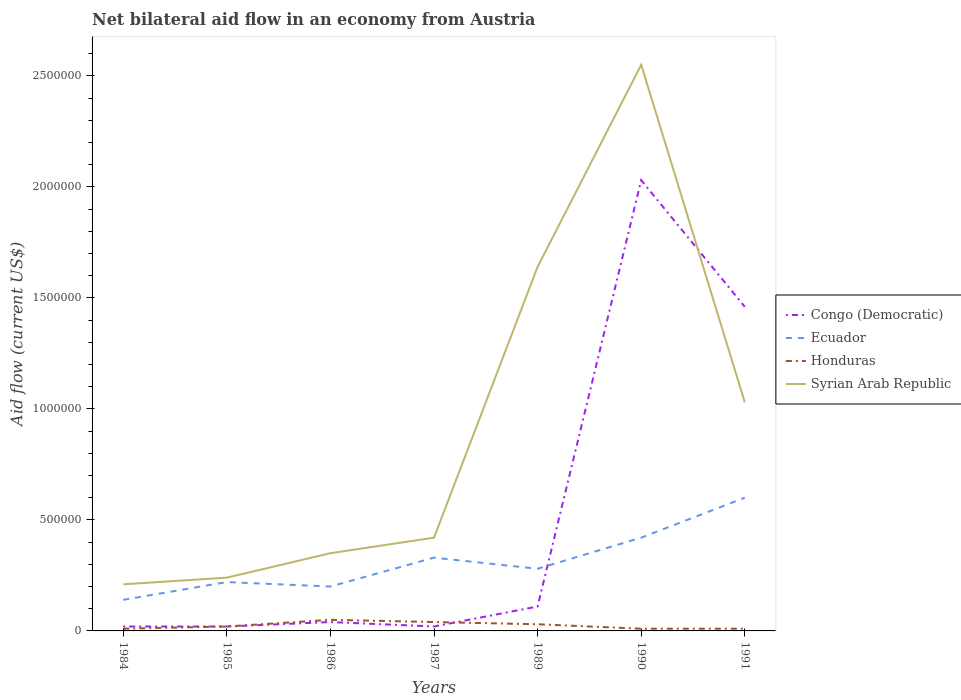How many different coloured lines are there?
Offer a very short reply. 4. Is the number of lines equal to the number of legend labels?
Keep it short and to the point. Yes. Across all years, what is the maximum net bilateral aid flow in Congo (Democratic)?
Ensure brevity in your answer.  2.00e+04. What is the total net bilateral aid flow in Ecuador in the graph?
Make the answer very short. -4.00e+05. What is the difference between the highest and the second highest net bilateral aid flow in Honduras?
Ensure brevity in your answer.  4.00e+04. How are the legend labels stacked?
Keep it short and to the point. Vertical. What is the title of the graph?
Your answer should be compact. Net bilateral aid flow in an economy from Austria. What is the label or title of the Y-axis?
Your answer should be very brief. Aid flow (current US$). What is the Aid flow (current US$) in Congo (Democratic) in 1984?
Your answer should be compact. 2.00e+04. What is the Aid flow (current US$) of Ecuador in 1984?
Provide a succinct answer. 1.40e+05. What is the Aid flow (current US$) of Congo (Democratic) in 1985?
Make the answer very short. 2.00e+04. What is the Aid flow (current US$) of Ecuador in 1985?
Make the answer very short. 2.20e+05. What is the Aid flow (current US$) in Honduras in 1985?
Ensure brevity in your answer.  2.00e+04. What is the Aid flow (current US$) of Syrian Arab Republic in 1985?
Your answer should be compact. 2.40e+05. What is the Aid flow (current US$) in Ecuador in 1986?
Ensure brevity in your answer.  2.00e+05. What is the Aid flow (current US$) of Honduras in 1986?
Offer a very short reply. 5.00e+04. What is the Aid flow (current US$) of Syrian Arab Republic in 1986?
Provide a short and direct response. 3.50e+05. What is the Aid flow (current US$) of Syrian Arab Republic in 1987?
Provide a succinct answer. 4.20e+05. What is the Aid flow (current US$) of Honduras in 1989?
Your answer should be very brief. 3.00e+04. What is the Aid flow (current US$) of Syrian Arab Republic in 1989?
Ensure brevity in your answer.  1.64e+06. What is the Aid flow (current US$) of Congo (Democratic) in 1990?
Provide a short and direct response. 2.03e+06. What is the Aid flow (current US$) of Ecuador in 1990?
Provide a short and direct response. 4.20e+05. What is the Aid flow (current US$) of Honduras in 1990?
Make the answer very short. 10000. What is the Aid flow (current US$) in Syrian Arab Republic in 1990?
Your response must be concise. 2.55e+06. What is the Aid flow (current US$) of Congo (Democratic) in 1991?
Provide a short and direct response. 1.46e+06. What is the Aid flow (current US$) in Honduras in 1991?
Ensure brevity in your answer.  10000. What is the Aid flow (current US$) of Syrian Arab Republic in 1991?
Your answer should be compact. 1.03e+06. Across all years, what is the maximum Aid flow (current US$) of Congo (Democratic)?
Keep it short and to the point. 2.03e+06. Across all years, what is the maximum Aid flow (current US$) of Honduras?
Ensure brevity in your answer.  5.00e+04. Across all years, what is the maximum Aid flow (current US$) in Syrian Arab Republic?
Make the answer very short. 2.55e+06. Across all years, what is the minimum Aid flow (current US$) of Congo (Democratic)?
Provide a succinct answer. 2.00e+04. Across all years, what is the minimum Aid flow (current US$) in Ecuador?
Keep it short and to the point. 1.40e+05. Across all years, what is the minimum Aid flow (current US$) in Honduras?
Offer a terse response. 10000. What is the total Aid flow (current US$) of Congo (Democratic) in the graph?
Make the answer very short. 3.70e+06. What is the total Aid flow (current US$) in Ecuador in the graph?
Your answer should be compact. 2.19e+06. What is the total Aid flow (current US$) in Syrian Arab Republic in the graph?
Ensure brevity in your answer.  6.44e+06. What is the difference between the Aid flow (current US$) of Congo (Democratic) in 1984 and that in 1985?
Your answer should be compact. 0. What is the difference between the Aid flow (current US$) of Ecuador in 1984 and that in 1985?
Offer a very short reply. -8.00e+04. What is the difference between the Aid flow (current US$) in Honduras in 1984 and that in 1985?
Offer a terse response. -10000. What is the difference between the Aid flow (current US$) in Congo (Democratic) in 1984 and that in 1986?
Offer a very short reply. -2.00e+04. What is the difference between the Aid flow (current US$) of Ecuador in 1984 and that in 1986?
Your answer should be compact. -6.00e+04. What is the difference between the Aid flow (current US$) in Congo (Democratic) in 1984 and that in 1987?
Your answer should be compact. 0. What is the difference between the Aid flow (current US$) in Ecuador in 1984 and that in 1987?
Offer a terse response. -1.90e+05. What is the difference between the Aid flow (current US$) in Syrian Arab Republic in 1984 and that in 1987?
Provide a short and direct response. -2.10e+05. What is the difference between the Aid flow (current US$) of Congo (Democratic) in 1984 and that in 1989?
Provide a short and direct response. -9.00e+04. What is the difference between the Aid flow (current US$) in Honduras in 1984 and that in 1989?
Provide a succinct answer. -2.00e+04. What is the difference between the Aid flow (current US$) of Syrian Arab Republic in 1984 and that in 1989?
Make the answer very short. -1.43e+06. What is the difference between the Aid flow (current US$) in Congo (Democratic) in 1984 and that in 1990?
Make the answer very short. -2.01e+06. What is the difference between the Aid flow (current US$) of Ecuador in 1984 and that in 1990?
Your answer should be compact. -2.80e+05. What is the difference between the Aid flow (current US$) of Honduras in 1984 and that in 1990?
Provide a short and direct response. 0. What is the difference between the Aid flow (current US$) of Syrian Arab Republic in 1984 and that in 1990?
Make the answer very short. -2.34e+06. What is the difference between the Aid flow (current US$) in Congo (Democratic) in 1984 and that in 1991?
Make the answer very short. -1.44e+06. What is the difference between the Aid flow (current US$) of Ecuador in 1984 and that in 1991?
Offer a terse response. -4.60e+05. What is the difference between the Aid flow (current US$) of Syrian Arab Republic in 1984 and that in 1991?
Offer a terse response. -8.20e+05. What is the difference between the Aid flow (current US$) in Ecuador in 1985 and that in 1986?
Ensure brevity in your answer.  2.00e+04. What is the difference between the Aid flow (current US$) of Honduras in 1985 and that in 1987?
Keep it short and to the point. -2.00e+04. What is the difference between the Aid flow (current US$) in Syrian Arab Republic in 1985 and that in 1987?
Provide a short and direct response. -1.80e+05. What is the difference between the Aid flow (current US$) in Ecuador in 1985 and that in 1989?
Your answer should be very brief. -6.00e+04. What is the difference between the Aid flow (current US$) of Honduras in 1985 and that in 1989?
Your answer should be very brief. -10000. What is the difference between the Aid flow (current US$) in Syrian Arab Republic in 1985 and that in 1989?
Offer a very short reply. -1.40e+06. What is the difference between the Aid flow (current US$) of Congo (Democratic) in 1985 and that in 1990?
Provide a short and direct response. -2.01e+06. What is the difference between the Aid flow (current US$) of Ecuador in 1985 and that in 1990?
Make the answer very short. -2.00e+05. What is the difference between the Aid flow (current US$) in Syrian Arab Republic in 1985 and that in 1990?
Make the answer very short. -2.31e+06. What is the difference between the Aid flow (current US$) of Congo (Democratic) in 1985 and that in 1991?
Provide a succinct answer. -1.44e+06. What is the difference between the Aid flow (current US$) in Ecuador in 1985 and that in 1991?
Your response must be concise. -3.80e+05. What is the difference between the Aid flow (current US$) of Honduras in 1985 and that in 1991?
Provide a short and direct response. 10000. What is the difference between the Aid flow (current US$) of Syrian Arab Republic in 1985 and that in 1991?
Keep it short and to the point. -7.90e+05. What is the difference between the Aid flow (current US$) of Congo (Democratic) in 1986 and that in 1987?
Your response must be concise. 2.00e+04. What is the difference between the Aid flow (current US$) of Ecuador in 1986 and that in 1987?
Provide a succinct answer. -1.30e+05. What is the difference between the Aid flow (current US$) of Honduras in 1986 and that in 1987?
Your answer should be compact. 10000. What is the difference between the Aid flow (current US$) in Ecuador in 1986 and that in 1989?
Make the answer very short. -8.00e+04. What is the difference between the Aid flow (current US$) in Honduras in 1986 and that in 1989?
Your answer should be very brief. 2.00e+04. What is the difference between the Aid flow (current US$) of Syrian Arab Republic in 1986 and that in 1989?
Your answer should be compact. -1.29e+06. What is the difference between the Aid flow (current US$) of Congo (Democratic) in 1986 and that in 1990?
Offer a terse response. -1.99e+06. What is the difference between the Aid flow (current US$) in Ecuador in 1986 and that in 1990?
Offer a terse response. -2.20e+05. What is the difference between the Aid flow (current US$) in Syrian Arab Republic in 1986 and that in 1990?
Your answer should be compact. -2.20e+06. What is the difference between the Aid flow (current US$) in Congo (Democratic) in 1986 and that in 1991?
Offer a terse response. -1.42e+06. What is the difference between the Aid flow (current US$) of Ecuador in 1986 and that in 1991?
Provide a short and direct response. -4.00e+05. What is the difference between the Aid flow (current US$) of Honduras in 1986 and that in 1991?
Ensure brevity in your answer.  4.00e+04. What is the difference between the Aid flow (current US$) in Syrian Arab Republic in 1986 and that in 1991?
Provide a succinct answer. -6.80e+05. What is the difference between the Aid flow (current US$) of Congo (Democratic) in 1987 and that in 1989?
Give a very brief answer. -9.00e+04. What is the difference between the Aid flow (current US$) of Syrian Arab Republic in 1987 and that in 1989?
Provide a succinct answer. -1.22e+06. What is the difference between the Aid flow (current US$) of Congo (Democratic) in 1987 and that in 1990?
Your answer should be compact. -2.01e+06. What is the difference between the Aid flow (current US$) in Honduras in 1987 and that in 1990?
Your response must be concise. 3.00e+04. What is the difference between the Aid flow (current US$) in Syrian Arab Republic in 1987 and that in 1990?
Keep it short and to the point. -2.13e+06. What is the difference between the Aid flow (current US$) in Congo (Democratic) in 1987 and that in 1991?
Make the answer very short. -1.44e+06. What is the difference between the Aid flow (current US$) of Ecuador in 1987 and that in 1991?
Provide a succinct answer. -2.70e+05. What is the difference between the Aid flow (current US$) in Syrian Arab Republic in 1987 and that in 1991?
Offer a terse response. -6.10e+05. What is the difference between the Aid flow (current US$) of Congo (Democratic) in 1989 and that in 1990?
Your answer should be compact. -1.92e+06. What is the difference between the Aid flow (current US$) of Honduras in 1989 and that in 1990?
Provide a short and direct response. 2.00e+04. What is the difference between the Aid flow (current US$) in Syrian Arab Republic in 1989 and that in 1990?
Offer a terse response. -9.10e+05. What is the difference between the Aid flow (current US$) of Congo (Democratic) in 1989 and that in 1991?
Your answer should be very brief. -1.35e+06. What is the difference between the Aid flow (current US$) in Ecuador in 1989 and that in 1991?
Provide a short and direct response. -3.20e+05. What is the difference between the Aid flow (current US$) in Honduras in 1989 and that in 1991?
Your answer should be compact. 2.00e+04. What is the difference between the Aid flow (current US$) of Congo (Democratic) in 1990 and that in 1991?
Provide a short and direct response. 5.70e+05. What is the difference between the Aid flow (current US$) of Ecuador in 1990 and that in 1991?
Your answer should be compact. -1.80e+05. What is the difference between the Aid flow (current US$) of Honduras in 1990 and that in 1991?
Keep it short and to the point. 0. What is the difference between the Aid flow (current US$) of Syrian Arab Republic in 1990 and that in 1991?
Offer a very short reply. 1.52e+06. What is the difference between the Aid flow (current US$) of Congo (Democratic) in 1984 and the Aid flow (current US$) of Honduras in 1985?
Your response must be concise. 0. What is the difference between the Aid flow (current US$) of Ecuador in 1984 and the Aid flow (current US$) of Honduras in 1985?
Your answer should be compact. 1.20e+05. What is the difference between the Aid flow (current US$) of Ecuador in 1984 and the Aid flow (current US$) of Syrian Arab Republic in 1985?
Your answer should be compact. -1.00e+05. What is the difference between the Aid flow (current US$) of Honduras in 1984 and the Aid flow (current US$) of Syrian Arab Republic in 1985?
Offer a terse response. -2.30e+05. What is the difference between the Aid flow (current US$) of Congo (Democratic) in 1984 and the Aid flow (current US$) of Honduras in 1986?
Make the answer very short. -3.00e+04. What is the difference between the Aid flow (current US$) in Congo (Democratic) in 1984 and the Aid flow (current US$) in Syrian Arab Republic in 1986?
Make the answer very short. -3.30e+05. What is the difference between the Aid flow (current US$) in Ecuador in 1984 and the Aid flow (current US$) in Honduras in 1986?
Your response must be concise. 9.00e+04. What is the difference between the Aid flow (current US$) of Congo (Democratic) in 1984 and the Aid flow (current US$) of Ecuador in 1987?
Offer a very short reply. -3.10e+05. What is the difference between the Aid flow (current US$) in Congo (Democratic) in 1984 and the Aid flow (current US$) in Syrian Arab Republic in 1987?
Keep it short and to the point. -4.00e+05. What is the difference between the Aid flow (current US$) of Ecuador in 1984 and the Aid flow (current US$) of Honduras in 1987?
Offer a very short reply. 1.00e+05. What is the difference between the Aid flow (current US$) of Ecuador in 1984 and the Aid flow (current US$) of Syrian Arab Republic in 1987?
Keep it short and to the point. -2.80e+05. What is the difference between the Aid flow (current US$) of Honduras in 1984 and the Aid flow (current US$) of Syrian Arab Republic in 1987?
Provide a short and direct response. -4.10e+05. What is the difference between the Aid flow (current US$) of Congo (Democratic) in 1984 and the Aid flow (current US$) of Ecuador in 1989?
Your answer should be very brief. -2.60e+05. What is the difference between the Aid flow (current US$) of Congo (Democratic) in 1984 and the Aid flow (current US$) of Honduras in 1989?
Give a very brief answer. -10000. What is the difference between the Aid flow (current US$) in Congo (Democratic) in 1984 and the Aid flow (current US$) in Syrian Arab Republic in 1989?
Offer a very short reply. -1.62e+06. What is the difference between the Aid flow (current US$) of Ecuador in 1984 and the Aid flow (current US$) of Honduras in 1989?
Offer a very short reply. 1.10e+05. What is the difference between the Aid flow (current US$) of Ecuador in 1984 and the Aid flow (current US$) of Syrian Arab Republic in 1989?
Provide a succinct answer. -1.50e+06. What is the difference between the Aid flow (current US$) in Honduras in 1984 and the Aid flow (current US$) in Syrian Arab Republic in 1989?
Offer a very short reply. -1.63e+06. What is the difference between the Aid flow (current US$) in Congo (Democratic) in 1984 and the Aid flow (current US$) in Ecuador in 1990?
Provide a short and direct response. -4.00e+05. What is the difference between the Aid flow (current US$) in Congo (Democratic) in 1984 and the Aid flow (current US$) in Syrian Arab Republic in 1990?
Offer a very short reply. -2.53e+06. What is the difference between the Aid flow (current US$) of Ecuador in 1984 and the Aid flow (current US$) of Honduras in 1990?
Offer a terse response. 1.30e+05. What is the difference between the Aid flow (current US$) of Ecuador in 1984 and the Aid flow (current US$) of Syrian Arab Republic in 1990?
Make the answer very short. -2.41e+06. What is the difference between the Aid flow (current US$) of Honduras in 1984 and the Aid flow (current US$) of Syrian Arab Republic in 1990?
Make the answer very short. -2.54e+06. What is the difference between the Aid flow (current US$) of Congo (Democratic) in 1984 and the Aid flow (current US$) of Ecuador in 1991?
Your response must be concise. -5.80e+05. What is the difference between the Aid flow (current US$) of Congo (Democratic) in 1984 and the Aid flow (current US$) of Syrian Arab Republic in 1991?
Offer a very short reply. -1.01e+06. What is the difference between the Aid flow (current US$) in Ecuador in 1984 and the Aid flow (current US$) in Syrian Arab Republic in 1991?
Your response must be concise. -8.90e+05. What is the difference between the Aid flow (current US$) of Honduras in 1984 and the Aid flow (current US$) of Syrian Arab Republic in 1991?
Give a very brief answer. -1.02e+06. What is the difference between the Aid flow (current US$) of Congo (Democratic) in 1985 and the Aid flow (current US$) of Syrian Arab Republic in 1986?
Ensure brevity in your answer.  -3.30e+05. What is the difference between the Aid flow (current US$) of Honduras in 1985 and the Aid flow (current US$) of Syrian Arab Republic in 1986?
Provide a short and direct response. -3.30e+05. What is the difference between the Aid flow (current US$) in Congo (Democratic) in 1985 and the Aid flow (current US$) in Ecuador in 1987?
Give a very brief answer. -3.10e+05. What is the difference between the Aid flow (current US$) in Congo (Democratic) in 1985 and the Aid flow (current US$) in Syrian Arab Republic in 1987?
Your response must be concise. -4.00e+05. What is the difference between the Aid flow (current US$) in Ecuador in 1985 and the Aid flow (current US$) in Honduras in 1987?
Provide a short and direct response. 1.80e+05. What is the difference between the Aid flow (current US$) of Honduras in 1985 and the Aid flow (current US$) of Syrian Arab Republic in 1987?
Provide a short and direct response. -4.00e+05. What is the difference between the Aid flow (current US$) in Congo (Democratic) in 1985 and the Aid flow (current US$) in Ecuador in 1989?
Provide a succinct answer. -2.60e+05. What is the difference between the Aid flow (current US$) in Congo (Democratic) in 1985 and the Aid flow (current US$) in Syrian Arab Republic in 1989?
Make the answer very short. -1.62e+06. What is the difference between the Aid flow (current US$) in Ecuador in 1985 and the Aid flow (current US$) in Syrian Arab Republic in 1989?
Your response must be concise. -1.42e+06. What is the difference between the Aid flow (current US$) of Honduras in 1985 and the Aid flow (current US$) of Syrian Arab Republic in 1989?
Offer a terse response. -1.62e+06. What is the difference between the Aid flow (current US$) in Congo (Democratic) in 1985 and the Aid flow (current US$) in Ecuador in 1990?
Your answer should be compact. -4.00e+05. What is the difference between the Aid flow (current US$) of Congo (Democratic) in 1985 and the Aid flow (current US$) of Honduras in 1990?
Provide a short and direct response. 10000. What is the difference between the Aid flow (current US$) of Congo (Democratic) in 1985 and the Aid flow (current US$) of Syrian Arab Republic in 1990?
Your answer should be very brief. -2.53e+06. What is the difference between the Aid flow (current US$) in Ecuador in 1985 and the Aid flow (current US$) in Honduras in 1990?
Ensure brevity in your answer.  2.10e+05. What is the difference between the Aid flow (current US$) of Ecuador in 1985 and the Aid flow (current US$) of Syrian Arab Republic in 1990?
Your answer should be very brief. -2.33e+06. What is the difference between the Aid flow (current US$) in Honduras in 1985 and the Aid flow (current US$) in Syrian Arab Republic in 1990?
Offer a very short reply. -2.53e+06. What is the difference between the Aid flow (current US$) of Congo (Democratic) in 1985 and the Aid flow (current US$) of Ecuador in 1991?
Keep it short and to the point. -5.80e+05. What is the difference between the Aid flow (current US$) of Congo (Democratic) in 1985 and the Aid flow (current US$) of Honduras in 1991?
Ensure brevity in your answer.  10000. What is the difference between the Aid flow (current US$) in Congo (Democratic) in 1985 and the Aid flow (current US$) in Syrian Arab Republic in 1991?
Keep it short and to the point. -1.01e+06. What is the difference between the Aid flow (current US$) in Ecuador in 1985 and the Aid flow (current US$) in Honduras in 1991?
Your response must be concise. 2.10e+05. What is the difference between the Aid flow (current US$) of Ecuador in 1985 and the Aid flow (current US$) of Syrian Arab Republic in 1991?
Your response must be concise. -8.10e+05. What is the difference between the Aid flow (current US$) of Honduras in 1985 and the Aid flow (current US$) of Syrian Arab Republic in 1991?
Ensure brevity in your answer.  -1.01e+06. What is the difference between the Aid flow (current US$) in Congo (Democratic) in 1986 and the Aid flow (current US$) in Ecuador in 1987?
Your answer should be very brief. -2.90e+05. What is the difference between the Aid flow (current US$) of Congo (Democratic) in 1986 and the Aid flow (current US$) of Honduras in 1987?
Your response must be concise. 0. What is the difference between the Aid flow (current US$) in Congo (Democratic) in 1986 and the Aid flow (current US$) in Syrian Arab Republic in 1987?
Offer a terse response. -3.80e+05. What is the difference between the Aid flow (current US$) in Ecuador in 1986 and the Aid flow (current US$) in Honduras in 1987?
Offer a terse response. 1.60e+05. What is the difference between the Aid flow (current US$) in Honduras in 1986 and the Aid flow (current US$) in Syrian Arab Republic in 1987?
Keep it short and to the point. -3.70e+05. What is the difference between the Aid flow (current US$) of Congo (Democratic) in 1986 and the Aid flow (current US$) of Ecuador in 1989?
Provide a succinct answer. -2.40e+05. What is the difference between the Aid flow (current US$) in Congo (Democratic) in 1986 and the Aid flow (current US$) in Honduras in 1989?
Offer a terse response. 10000. What is the difference between the Aid flow (current US$) in Congo (Democratic) in 1986 and the Aid flow (current US$) in Syrian Arab Republic in 1989?
Provide a succinct answer. -1.60e+06. What is the difference between the Aid flow (current US$) of Ecuador in 1986 and the Aid flow (current US$) of Honduras in 1989?
Your response must be concise. 1.70e+05. What is the difference between the Aid flow (current US$) of Ecuador in 1986 and the Aid flow (current US$) of Syrian Arab Republic in 1989?
Offer a very short reply. -1.44e+06. What is the difference between the Aid flow (current US$) of Honduras in 1986 and the Aid flow (current US$) of Syrian Arab Republic in 1989?
Your answer should be very brief. -1.59e+06. What is the difference between the Aid flow (current US$) in Congo (Democratic) in 1986 and the Aid flow (current US$) in Ecuador in 1990?
Your response must be concise. -3.80e+05. What is the difference between the Aid flow (current US$) of Congo (Democratic) in 1986 and the Aid flow (current US$) of Honduras in 1990?
Provide a succinct answer. 3.00e+04. What is the difference between the Aid flow (current US$) in Congo (Democratic) in 1986 and the Aid flow (current US$) in Syrian Arab Republic in 1990?
Offer a very short reply. -2.51e+06. What is the difference between the Aid flow (current US$) of Ecuador in 1986 and the Aid flow (current US$) of Syrian Arab Republic in 1990?
Your answer should be compact. -2.35e+06. What is the difference between the Aid flow (current US$) in Honduras in 1986 and the Aid flow (current US$) in Syrian Arab Republic in 1990?
Ensure brevity in your answer.  -2.50e+06. What is the difference between the Aid flow (current US$) of Congo (Democratic) in 1986 and the Aid flow (current US$) of Ecuador in 1991?
Keep it short and to the point. -5.60e+05. What is the difference between the Aid flow (current US$) in Congo (Democratic) in 1986 and the Aid flow (current US$) in Honduras in 1991?
Your answer should be very brief. 3.00e+04. What is the difference between the Aid flow (current US$) of Congo (Democratic) in 1986 and the Aid flow (current US$) of Syrian Arab Republic in 1991?
Provide a short and direct response. -9.90e+05. What is the difference between the Aid flow (current US$) in Ecuador in 1986 and the Aid flow (current US$) in Honduras in 1991?
Your response must be concise. 1.90e+05. What is the difference between the Aid flow (current US$) of Ecuador in 1986 and the Aid flow (current US$) of Syrian Arab Republic in 1991?
Keep it short and to the point. -8.30e+05. What is the difference between the Aid flow (current US$) of Honduras in 1986 and the Aid flow (current US$) of Syrian Arab Republic in 1991?
Make the answer very short. -9.80e+05. What is the difference between the Aid flow (current US$) of Congo (Democratic) in 1987 and the Aid flow (current US$) of Honduras in 1989?
Provide a short and direct response. -10000. What is the difference between the Aid flow (current US$) of Congo (Democratic) in 1987 and the Aid flow (current US$) of Syrian Arab Republic in 1989?
Provide a succinct answer. -1.62e+06. What is the difference between the Aid flow (current US$) in Ecuador in 1987 and the Aid flow (current US$) in Honduras in 1989?
Keep it short and to the point. 3.00e+05. What is the difference between the Aid flow (current US$) of Ecuador in 1987 and the Aid flow (current US$) of Syrian Arab Republic in 1989?
Ensure brevity in your answer.  -1.31e+06. What is the difference between the Aid flow (current US$) in Honduras in 1987 and the Aid flow (current US$) in Syrian Arab Republic in 1989?
Provide a short and direct response. -1.60e+06. What is the difference between the Aid flow (current US$) in Congo (Democratic) in 1987 and the Aid flow (current US$) in Ecuador in 1990?
Your response must be concise. -4.00e+05. What is the difference between the Aid flow (current US$) of Congo (Democratic) in 1987 and the Aid flow (current US$) of Syrian Arab Republic in 1990?
Provide a succinct answer. -2.53e+06. What is the difference between the Aid flow (current US$) in Ecuador in 1987 and the Aid flow (current US$) in Syrian Arab Republic in 1990?
Make the answer very short. -2.22e+06. What is the difference between the Aid flow (current US$) of Honduras in 1987 and the Aid flow (current US$) of Syrian Arab Republic in 1990?
Your response must be concise. -2.51e+06. What is the difference between the Aid flow (current US$) in Congo (Democratic) in 1987 and the Aid flow (current US$) in Ecuador in 1991?
Offer a terse response. -5.80e+05. What is the difference between the Aid flow (current US$) in Congo (Democratic) in 1987 and the Aid flow (current US$) in Syrian Arab Republic in 1991?
Provide a short and direct response. -1.01e+06. What is the difference between the Aid flow (current US$) in Ecuador in 1987 and the Aid flow (current US$) in Honduras in 1991?
Your answer should be very brief. 3.20e+05. What is the difference between the Aid flow (current US$) in Ecuador in 1987 and the Aid flow (current US$) in Syrian Arab Republic in 1991?
Offer a very short reply. -7.00e+05. What is the difference between the Aid flow (current US$) of Honduras in 1987 and the Aid flow (current US$) of Syrian Arab Republic in 1991?
Give a very brief answer. -9.90e+05. What is the difference between the Aid flow (current US$) of Congo (Democratic) in 1989 and the Aid flow (current US$) of Ecuador in 1990?
Your response must be concise. -3.10e+05. What is the difference between the Aid flow (current US$) of Congo (Democratic) in 1989 and the Aid flow (current US$) of Honduras in 1990?
Ensure brevity in your answer.  1.00e+05. What is the difference between the Aid flow (current US$) of Congo (Democratic) in 1989 and the Aid flow (current US$) of Syrian Arab Republic in 1990?
Give a very brief answer. -2.44e+06. What is the difference between the Aid flow (current US$) of Ecuador in 1989 and the Aid flow (current US$) of Honduras in 1990?
Make the answer very short. 2.70e+05. What is the difference between the Aid flow (current US$) in Ecuador in 1989 and the Aid flow (current US$) in Syrian Arab Republic in 1990?
Ensure brevity in your answer.  -2.27e+06. What is the difference between the Aid flow (current US$) in Honduras in 1989 and the Aid flow (current US$) in Syrian Arab Republic in 1990?
Ensure brevity in your answer.  -2.52e+06. What is the difference between the Aid flow (current US$) in Congo (Democratic) in 1989 and the Aid flow (current US$) in Ecuador in 1991?
Your answer should be very brief. -4.90e+05. What is the difference between the Aid flow (current US$) in Congo (Democratic) in 1989 and the Aid flow (current US$) in Syrian Arab Republic in 1991?
Make the answer very short. -9.20e+05. What is the difference between the Aid flow (current US$) of Ecuador in 1989 and the Aid flow (current US$) of Honduras in 1991?
Keep it short and to the point. 2.70e+05. What is the difference between the Aid flow (current US$) of Ecuador in 1989 and the Aid flow (current US$) of Syrian Arab Republic in 1991?
Your answer should be compact. -7.50e+05. What is the difference between the Aid flow (current US$) of Congo (Democratic) in 1990 and the Aid flow (current US$) of Ecuador in 1991?
Give a very brief answer. 1.43e+06. What is the difference between the Aid flow (current US$) in Congo (Democratic) in 1990 and the Aid flow (current US$) in Honduras in 1991?
Offer a terse response. 2.02e+06. What is the difference between the Aid flow (current US$) in Congo (Democratic) in 1990 and the Aid flow (current US$) in Syrian Arab Republic in 1991?
Ensure brevity in your answer.  1.00e+06. What is the difference between the Aid flow (current US$) of Ecuador in 1990 and the Aid flow (current US$) of Honduras in 1991?
Give a very brief answer. 4.10e+05. What is the difference between the Aid flow (current US$) in Ecuador in 1990 and the Aid flow (current US$) in Syrian Arab Republic in 1991?
Ensure brevity in your answer.  -6.10e+05. What is the difference between the Aid flow (current US$) in Honduras in 1990 and the Aid flow (current US$) in Syrian Arab Republic in 1991?
Ensure brevity in your answer.  -1.02e+06. What is the average Aid flow (current US$) in Congo (Democratic) per year?
Keep it short and to the point. 5.29e+05. What is the average Aid flow (current US$) of Ecuador per year?
Your answer should be compact. 3.13e+05. What is the average Aid flow (current US$) in Honduras per year?
Give a very brief answer. 2.43e+04. What is the average Aid flow (current US$) in Syrian Arab Republic per year?
Provide a short and direct response. 9.20e+05. In the year 1984, what is the difference between the Aid flow (current US$) in Congo (Democratic) and Aid flow (current US$) in Honduras?
Your answer should be compact. 10000. In the year 1985, what is the difference between the Aid flow (current US$) of Congo (Democratic) and Aid flow (current US$) of Ecuador?
Give a very brief answer. -2.00e+05. In the year 1985, what is the difference between the Aid flow (current US$) in Congo (Democratic) and Aid flow (current US$) in Honduras?
Offer a terse response. 0. In the year 1985, what is the difference between the Aid flow (current US$) in Congo (Democratic) and Aid flow (current US$) in Syrian Arab Republic?
Keep it short and to the point. -2.20e+05. In the year 1985, what is the difference between the Aid flow (current US$) in Ecuador and Aid flow (current US$) in Honduras?
Your response must be concise. 2.00e+05. In the year 1986, what is the difference between the Aid flow (current US$) of Congo (Democratic) and Aid flow (current US$) of Ecuador?
Offer a very short reply. -1.60e+05. In the year 1986, what is the difference between the Aid flow (current US$) in Congo (Democratic) and Aid flow (current US$) in Honduras?
Ensure brevity in your answer.  -10000. In the year 1986, what is the difference between the Aid flow (current US$) of Congo (Democratic) and Aid flow (current US$) of Syrian Arab Republic?
Your response must be concise. -3.10e+05. In the year 1986, what is the difference between the Aid flow (current US$) in Honduras and Aid flow (current US$) in Syrian Arab Republic?
Your response must be concise. -3.00e+05. In the year 1987, what is the difference between the Aid flow (current US$) in Congo (Democratic) and Aid flow (current US$) in Ecuador?
Your response must be concise. -3.10e+05. In the year 1987, what is the difference between the Aid flow (current US$) of Congo (Democratic) and Aid flow (current US$) of Honduras?
Give a very brief answer. -2.00e+04. In the year 1987, what is the difference between the Aid flow (current US$) of Congo (Democratic) and Aid flow (current US$) of Syrian Arab Republic?
Give a very brief answer. -4.00e+05. In the year 1987, what is the difference between the Aid flow (current US$) of Ecuador and Aid flow (current US$) of Syrian Arab Republic?
Keep it short and to the point. -9.00e+04. In the year 1987, what is the difference between the Aid flow (current US$) in Honduras and Aid flow (current US$) in Syrian Arab Republic?
Provide a succinct answer. -3.80e+05. In the year 1989, what is the difference between the Aid flow (current US$) in Congo (Democratic) and Aid flow (current US$) in Ecuador?
Ensure brevity in your answer.  -1.70e+05. In the year 1989, what is the difference between the Aid flow (current US$) of Congo (Democratic) and Aid flow (current US$) of Honduras?
Give a very brief answer. 8.00e+04. In the year 1989, what is the difference between the Aid flow (current US$) of Congo (Democratic) and Aid flow (current US$) of Syrian Arab Republic?
Your response must be concise. -1.53e+06. In the year 1989, what is the difference between the Aid flow (current US$) in Ecuador and Aid flow (current US$) in Syrian Arab Republic?
Keep it short and to the point. -1.36e+06. In the year 1989, what is the difference between the Aid flow (current US$) of Honduras and Aid flow (current US$) of Syrian Arab Republic?
Offer a terse response. -1.61e+06. In the year 1990, what is the difference between the Aid flow (current US$) of Congo (Democratic) and Aid flow (current US$) of Ecuador?
Your answer should be very brief. 1.61e+06. In the year 1990, what is the difference between the Aid flow (current US$) of Congo (Democratic) and Aid flow (current US$) of Honduras?
Offer a terse response. 2.02e+06. In the year 1990, what is the difference between the Aid flow (current US$) of Congo (Democratic) and Aid flow (current US$) of Syrian Arab Republic?
Ensure brevity in your answer.  -5.20e+05. In the year 1990, what is the difference between the Aid flow (current US$) of Ecuador and Aid flow (current US$) of Honduras?
Your response must be concise. 4.10e+05. In the year 1990, what is the difference between the Aid flow (current US$) in Ecuador and Aid flow (current US$) in Syrian Arab Republic?
Provide a succinct answer. -2.13e+06. In the year 1990, what is the difference between the Aid flow (current US$) in Honduras and Aid flow (current US$) in Syrian Arab Republic?
Your response must be concise. -2.54e+06. In the year 1991, what is the difference between the Aid flow (current US$) of Congo (Democratic) and Aid flow (current US$) of Ecuador?
Make the answer very short. 8.60e+05. In the year 1991, what is the difference between the Aid flow (current US$) of Congo (Democratic) and Aid flow (current US$) of Honduras?
Give a very brief answer. 1.45e+06. In the year 1991, what is the difference between the Aid flow (current US$) in Ecuador and Aid flow (current US$) in Honduras?
Offer a terse response. 5.90e+05. In the year 1991, what is the difference between the Aid flow (current US$) in Ecuador and Aid flow (current US$) in Syrian Arab Republic?
Give a very brief answer. -4.30e+05. In the year 1991, what is the difference between the Aid flow (current US$) of Honduras and Aid flow (current US$) of Syrian Arab Republic?
Your answer should be compact. -1.02e+06. What is the ratio of the Aid flow (current US$) in Ecuador in 1984 to that in 1985?
Ensure brevity in your answer.  0.64. What is the ratio of the Aid flow (current US$) in Honduras in 1984 to that in 1985?
Offer a very short reply. 0.5. What is the ratio of the Aid flow (current US$) in Congo (Democratic) in 1984 to that in 1986?
Ensure brevity in your answer.  0.5. What is the ratio of the Aid flow (current US$) of Syrian Arab Republic in 1984 to that in 1986?
Make the answer very short. 0.6. What is the ratio of the Aid flow (current US$) in Congo (Democratic) in 1984 to that in 1987?
Give a very brief answer. 1. What is the ratio of the Aid flow (current US$) of Ecuador in 1984 to that in 1987?
Ensure brevity in your answer.  0.42. What is the ratio of the Aid flow (current US$) of Honduras in 1984 to that in 1987?
Keep it short and to the point. 0.25. What is the ratio of the Aid flow (current US$) in Congo (Democratic) in 1984 to that in 1989?
Your response must be concise. 0.18. What is the ratio of the Aid flow (current US$) in Ecuador in 1984 to that in 1989?
Offer a terse response. 0.5. What is the ratio of the Aid flow (current US$) of Honduras in 1984 to that in 1989?
Offer a terse response. 0.33. What is the ratio of the Aid flow (current US$) of Syrian Arab Republic in 1984 to that in 1989?
Offer a very short reply. 0.13. What is the ratio of the Aid flow (current US$) of Congo (Democratic) in 1984 to that in 1990?
Offer a terse response. 0.01. What is the ratio of the Aid flow (current US$) in Honduras in 1984 to that in 1990?
Offer a very short reply. 1. What is the ratio of the Aid flow (current US$) in Syrian Arab Republic in 1984 to that in 1990?
Your response must be concise. 0.08. What is the ratio of the Aid flow (current US$) in Congo (Democratic) in 1984 to that in 1991?
Provide a succinct answer. 0.01. What is the ratio of the Aid flow (current US$) in Ecuador in 1984 to that in 1991?
Your answer should be compact. 0.23. What is the ratio of the Aid flow (current US$) of Honduras in 1984 to that in 1991?
Make the answer very short. 1. What is the ratio of the Aid flow (current US$) in Syrian Arab Republic in 1984 to that in 1991?
Your response must be concise. 0.2. What is the ratio of the Aid flow (current US$) in Congo (Democratic) in 1985 to that in 1986?
Make the answer very short. 0.5. What is the ratio of the Aid flow (current US$) in Ecuador in 1985 to that in 1986?
Make the answer very short. 1.1. What is the ratio of the Aid flow (current US$) in Syrian Arab Republic in 1985 to that in 1986?
Offer a terse response. 0.69. What is the ratio of the Aid flow (current US$) in Congo (Democratic) in 1985 to that in 1989?
Ensure brevity in your answer.  0.18. What is the ratio of the Aid flow (current US$) of Ecuador in 1985 to that in 1989?
Offer a terse response. 0.79. What is the ratio of the Aid flow (current US$) in Syrian Arab Republic in 1985 to that in 1989?
Your answer should be very brief. 0.15. What is the ratio of the Aid flow (current US$) in Congo (Democratic) in 1985 to that in 1990?
Your answer should be compact. 0.01. What is the ratio of the Aid flow (current US$) in Ecuador in 1985 to that in 1990?
Make the answer very short. 0.52. What is the ratio of the Aid flow (current US$) in Syrian Arab Republic in 1985 to that in 1990?
Offer a terse response. 0.09. What is the ratio of the Aid flow (current US$) of Congo (Democratic) in 1985 to that in 1991?
Ensure brevity in your answer.  0.01. What is the ratio of the Aid flow (current US$) in Ecuador in 1985 to that in 1991?
Your answer should be compact. 0.37. What is the ratio of the Aid flow (current US$) in Honduras in 1985 to that in 1991?
Your response must be concise. 2. What is the ratio of the Aid flow (current US$) in Syrian Arab Republic in 1985 to that in 1991?
Your response must be concise. 0.23. What is the ratio of the Aid flow (current US$) in Congo (Democratic) in 1986 to that in 1987?
Your answer should be compact. 2. What is the ratio of the Aid flow (current US$) in Ecuador in 1986 to that in 1987?
Make the answer very short. 0.61. What is the ratio of the Aid flow (current US$) of Congo (Democratic) in 1986 to that in 1989?
Give a very brief answer. 0.36. What is the ratio of the Aid flow (current US$) of Honduras in 1986 to that in 1989?
Your response must be concise. 1.67. What is the ratio of the Aid flow (current US$) of Syrian Arab Republic in 1986 to that in 1989?
Offer a very short reply. 0.21. What is the ratio of the Aid flow (current US$) in Congo (Democratic) in 1986 to that in 1990?
Provide a succinct answer. 0.02. What is the ratio of the Aid flow (current US$) in Ecuador in 1986 to that in 1990?
Keep it short and to the point. 0.48. What is the ratio of the Aid flow (current US$) of Honduras in 1986 to that in 1990?
Offer a very short reply. 5. What is the ratio of the Aid flow (current US$) in Syrian Arab Republic in 1986 to that in 1990?
Offer a terse response. 0.14. What is the ratio of the Aid flow (current US$) of Congo (Democratic) in 1986 to that in 1991?
Give a very brief answer. 0.03. What is the ratio of the Aid flow (current US$) in Ecuador in 1986 to that in 1991?
Keep it short and to the point. 0.33. What is the ratio of the Aid flow (current US$) of Syrian Arab Republic in 1986 to that in 1991?
Offer a terse response. 0.34. What is the ratio of the Aid flow (current US$) of Congo (Democratic) in 1987 to that in 1989?
Your response must be concise. 0.18. What is the ratio of the Aid flow (current US$) in Ecuador in 1987 to that in 1989?
Offer a terse response. 1.18. What is the ratio of the Aid flow (current US$) of Syrian Arab Republic in 1987 to that in 1989?
Provide a short and direct response. 0.26. What is the ratio of the Aid flow (current US$) of Congo (Democratic) in 1987 to that in 1990?
Make the answer very short. 0.01. What is the ratio of the Aid flow (current US$) of Ecuador in 1987 to that in 1990?
Offer a very short reply. 0.79. What is the ratio of the Aid flow (current US$) of Honduras in 1987 to that in 1990?
Give a very brief answer. 4. What is the ratio of the Aid flow (current US$) in Syrian Arab Republic in 1987 to that in 1990?
Provide a short and direct response. 0.16. What is the ratio of the Aid flow (current US$) in Congo (Democratic) in 1987 to that in 1991?
Your answer should be compact. 0.01. What is the ratio of the Aid flow (current US$) of Ecuador in 1987 to that in 1991?
Provide a short and direct response. 0.55. What is the ratio of the Aid flow (current US$) of Honduras in 1987 to that in 1991?
Offer a very short reply. 4. What is the ratio of the Aid flow (current US$) in Syrian Arab Republic in 1987 to that in 1991?
Keep it short and to the point. 0.41. What is the ratio of the Aid flow (current US$) in Congo (Democratic) in 1989 to that in 1990?
Your answer should be very brief. 0.05. What is the ratio of the Aid flow (current US$) of Ecuador in 1989 to that in 1990?
Your answer should be very brief. 0.67. What is the ratio of the Aid flow (current US$) in Syrian Arab Republic in 1989 to that in 1990?
Your response must be concise. 0.64. What is the ratio of the Aid flow (current US$) in Congo (Democratic) in 1989 to that in 1991?
Your response must be concise. 0.08. What is the ratio of the Aid flow (current US$) of Ecuador in 1989 to that in 1991?
Provide a short and direct response. 0.47. What is the ratio of the Aid flow (current US$) of Syrian Arab Republic in 1989 to that in 1991?
Make the answer very short. 1.59. What is the ratio of the Aid flow (current US$) in Congo (Democratic) in 1990 to that in 1991?
Your answer should be compact. 1.39. What is the ratio of the Aid flow (current US$) of Ecuador in 1990 to that in 1991?
Your response must be concise. 0.7. What is the ratio of the Aid flow (current US$) of Syrian Arab Republic in 1990 to that in 1991?
Provide a succinct answer. 2.48. What is the difference between the highest and the second highest Aid flow (current US$) in Congo (Democratic)?
Give a very brief answer. 5.70e+05. What is the difference between the highest and the second highest Aid flow (current US$) in Honduras?
Your answer should be compact. 10000. What is the difference between the highest and the second highest Aid flow (current US$) in Syrian Arab Republic?
Make the answer very short. 9.10e+05. What is the difference between the highest and the lowest Aid flow (current US$) of Congo (Democratic)?
Your answer should be very brief. 2.01e+06. What is the difference between the highest and the lowest Aid flow (current US$) of Syrian Arab Republic?
Your response must be concise. 2.34e+06. 